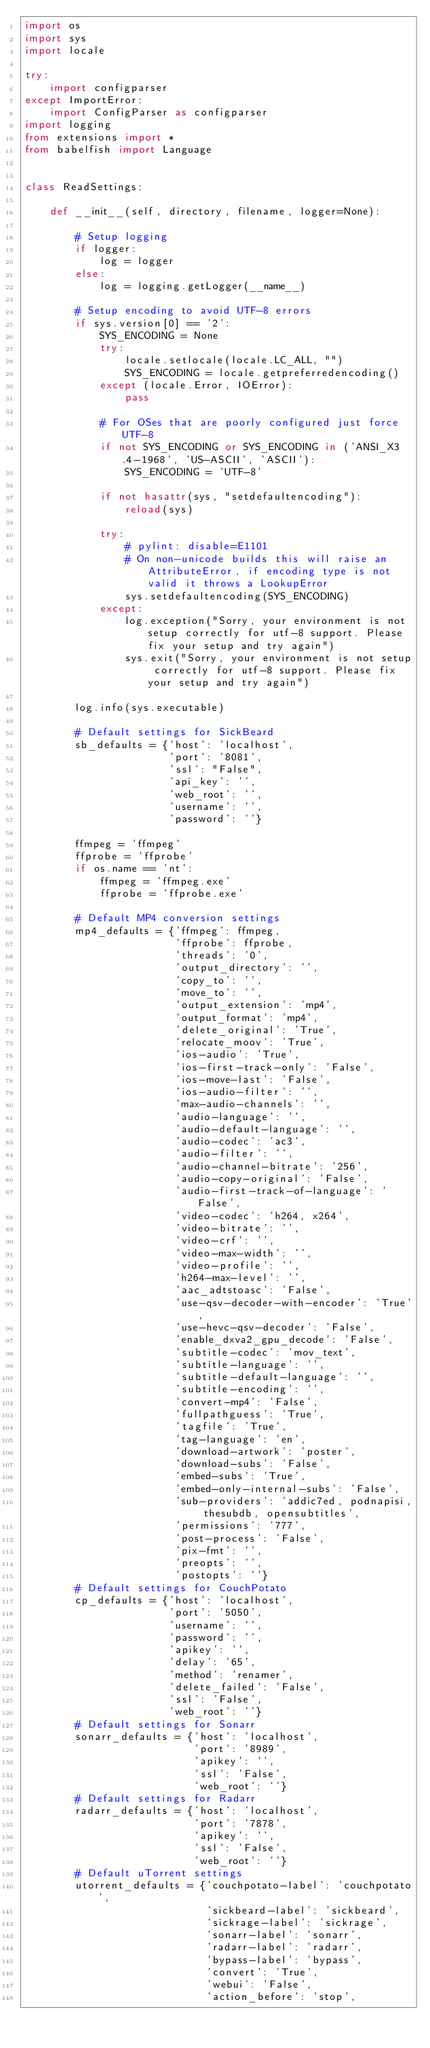Convert code to text. <code><loc_0><loc_0><loc_500><loc_500><_Python_>import os
import sys
import locale

try:
    import configparser
except ImportError:
    import ConfigParser as configparser
import logging
from extensions import *
from babelfish import Language


class ReadSettings:

    def __init__(self, directory, filename, logger=None):

        # Setup logging
        if logger:
            log = logger
        else:
            log = logging.getLogger(__name__)

        # Setup encoding to avoid UTF-8 errors
        if sys.version[0] == '2':
            SYS_ENCODING = None
            try:
                locale.setlocale(locale.LC_ALL, "")
                SYS_ENCODING = locale.getpreferredencoding()
            except (locale.Error, IOError):
                pass

            # For OSes that are poorly configured just force UTF-8
            if not SYS_ENCODING or SYS_ENCODING in ('ANSI_X3.4-1968', 'US-ASCII', 'ASCII'):
                SYS_ENCODING = 'UTF-8'

            if not hasattr(sys, "setdefaultencoding"):
                reload(sys)

            try:
                # pylint: disable=E1101
                # On non-unicode builds this will raise an AttributeError, if encoding type is not valid it throws a LookupError
                sys.setdefaultencoding(SYS_ENCODING)
            except:
                log.exception("Sorry, your environment is not setup correctly for utf-8 support. Please fix your setup and try again")
                sys.exit("Sorry, your environment is not setup correctly for utf-8 support. Please fix your setup and try again")

        log.info(sys.executable)

        # Default settings for SickBeard
        sb_defaults = {'host': 'localhost',
                       'port': '8081',
                       'ssl': "False",
                       'api_key': '',
                       'web_root': '',
                       'username': '',
                       'password': ''}

        ffmpeg = 'ffmpeg'
        ffprobe = 'ffprobe'
        if os.name == 'nt':
            ffmpeg = 'ffmpeg.exe'
            ffprobe = 'ffprobe.exe'

        # Default MP4 conversion settings
        mp4_defaults = {'ffmpeg': ffmpeg,
                        'ffprobe': ffprobe,
                        'threads': '0',
                        'output_directory': '',
                        'copy_to': '',
                        'move_to': '',
                        'output_extension': 'mp4',
                        'output_format': 'mp4',
                        'delete_original': 'True',
                        'relocate_moov': 'True',
                        'ios-audio': 'True',
                        'ios-first-track-only': 'False',
                        'ios-move-last': 'False',
                        'ios-audio-filter': '',
                        'max-audio-channels': '',
                        'audio-language': '',
                        'audio-default-language': '',
                        'audio-codec': 'ac3',
                        'audio-filter': '',
                        'audio-channel-bitrate': '256',
                        'audio-copy-original': 'False',
                        'audio-first-track-of-language': 'False',
                        'video-codec': 'h264, x264',
                        'video-bitrate': '',
                        'video-crf': '',
                        'video-max-width': '',
                        'video-profile': '',
                        'h264-max-level': '',
                        'aac_adtstoasc': 'False',
                        'use-qsv-decoder-with-encoder': 'True',
                        'use-hevc-qsv-decoder': 'False',
                        'enable_dxva2_gpu_decode': 'False',
                        'subtitle-codec': 'mov_text',
                        'subtitle-language': '',
                        'subtitle-default-language': '',
                        'subtitle-encoding': '',
                        'convert-mp4': 'False',
                        'fullpathguess': 'True',
                        'tagfile': 'True',
                        'tag-language': 'en',
                        'download-artwork': 'poster',
                        'download-subs': 'False',
                        'embed-subs': 'True',
                        'embed-only-internal-subs': 'False',
                        'sub-providers': 'addic7ed, podnapisi, thesubdb, opensubtitles',
                        'permissions': '777',
                        'post-process': 'False',
                        'pix-fmt': '',
                        'preopts': '',
                        'postopts': ''}
        # Default settings for CouchPotato
        cp_defaults = {'host': 'localhost',
                       'port': '5050',
                       'username': '',
                       'password': '',
                       'apikey': '',
                       'delay': '65',
                       'method': 'renamer',
                       'delete_failed': 'False',
                       'ssl': 'False',
                       'web_root': ''}
        # Default settings for Sonarr
        sonarr_defaults = {'host': 'localhost',
                           'port': '8989',
                           'apikey': '',
                           'ssl': 'False',
                           'web_root': ''}
        # Default settings for Radarr
        radarr_defaults = {'host': 'localhost',
                           'port': '7878',
                           'apikey': '',
                           'ssl': 'False',
                           'web_root': ''}
        # Default uTorrent settings
        utorrent_defaults = {'couchpotato-label': 'couchpotato',
                             'sickbeard-label': 'sickbeard',
                             'sickrage-label': 'sickrage',
                             'sonarr-label': 'sonarr',
                             'radarr-label': 'radarr',
                             'bypass-label': 'bypass',
                             'convert': 'True',
                             'webui': 'False',
                             'action_before': 'stop',</code> 